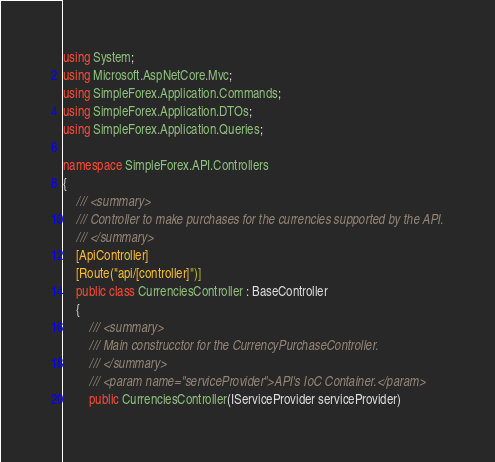Convert code to text. <code><loc_0><loc_0><loc_500><loc_500><_C#_>using System;
using Microsoft.AspNetCore.Mvc;
using SimpleForex.Application.Commands;
using SimpleForex.Application.DTOs;
using SimpleForex.Application.Queries;

namespace SimpleForex.API.Controllers
{
    /// <summary>
    /// Controller to make purchases for the currencies supported by the API.
    /// </summary>
    [ApiController]
    [Route("api/[controller]")]
    public class CurrenciesController : BaseController
    {
        /// <summary>
        /// Main construcctor for the CurrencyPurchaseController.
        /// </summary>
        /// <param name="serviceProvider">API's IoC Container.</param>
        public CurrenciesController(IServiceProvider serviceProvider)</code> 